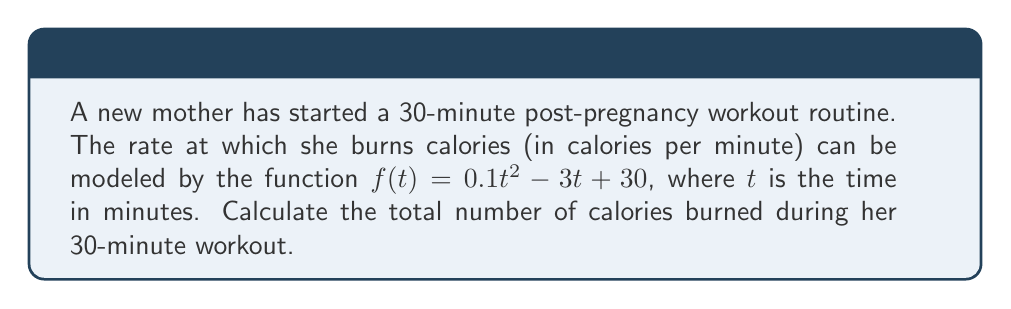Can you solve this math problem? To find the total number of calories burned, we need to calculate the area under the curve of $f(t)$ from $t=0$ to $t=30$. This can be done using definite integration.

1) The integral we need to evaluate is:
   $$\int_0^{30} (0.1t^2 - 3t + 30) dt$$

2) Integrate each term:
   $$\left[ \frac{0.1t^3}{3} - \frac{3t^2}{2} + 30t \right]_0^{30}$$

3) Evaluate at the upper and lower bounds:
   $$\left(\frac{0.1(30)^3}{3} - \frac{3(30)^2}{2} + 30(30)\right) - \left(\frac{0.1(0)^3}{3} - \frac{3(0)^2}{2} + 30(0)\right)$$

4) Simplify:
   $$\left(900 - 1350 + 900\right) - (0)$$
   $$= 450$$

Therefore, the total number of calories burned during the 30-minute workout is 450 calories.
Answer: 450 calories 